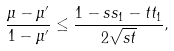<formula> <loc_0><loc_0><loc_500><loc_500>\frac { \mu - \mu ^ { \prime } } { 1 - \mu ^ { \prime } } \leq \frac { 1 - s s _ { 1 } - t t _ { 1 } } { 2 \sqrt { s t } } ,</formula> 